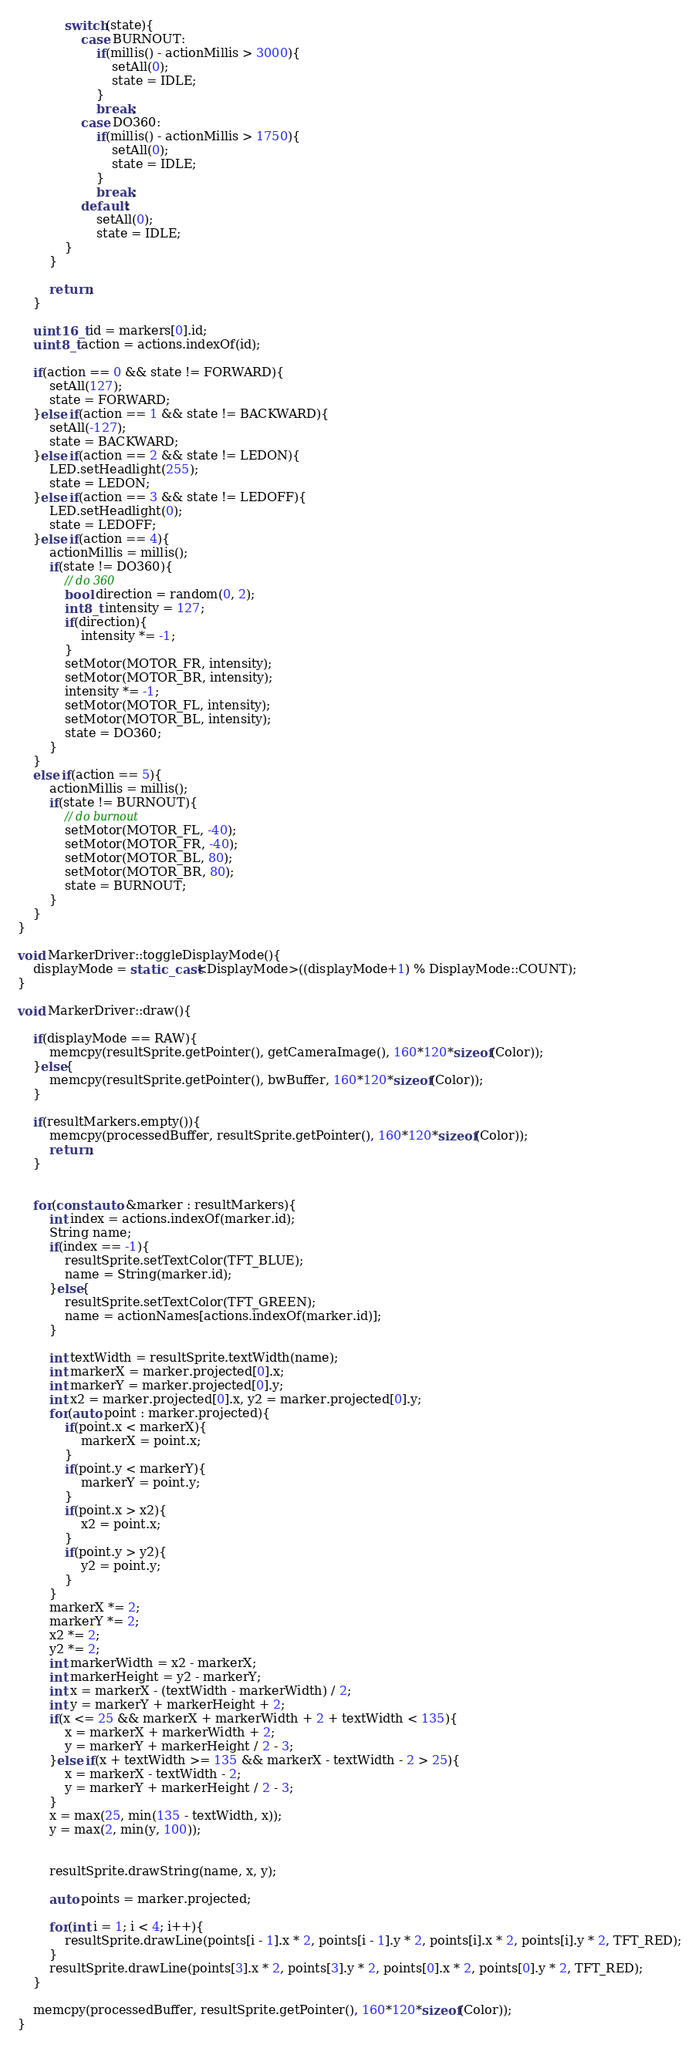Convert code to text. <code><loc_0><loc_0><loc_500><loc_500><_C++_>			switch(state){
				case BURNOUT:
					if(millis() - actionMillis > 3000){
						setAll(0);
						state = IDLE;
					}
					break;
				case DO360:
					if(millis() - actionMillis > 1750){
						setAll(0);
						state = IDLE;
					}
					break;
				default:
					setAll(0);
					state = IDLE;
			}
		}

		return;
	}

	uint16_t id = markers[0].id;
	uint8_t action = actions.indexOf(id);

	if(action == 0 && state != FORWARD){
		setAll(127);
		state = FORWARD;
	}else if(action == 1 && state != BACKWARD){
		setAll(-127);
		state = BACKWARD;
	}else if(action == 2 && state != LEDON){
		LED.setHeadlight(255);
		state = LEDON;
	}else if(action == 3 && state != LEDOFF){
		LED.setHeadlight(0);
		state = LEDOFF;
	}else if(action == 4){
		actionMillis = millis();
		if(state != DO360){
			// do 360
			bool direction = random(0, 2);
			int8_t intensity = 127;
			if(direction){
				intensity *= -1;
			}
			setMotor(MOTOR_FR, intensity);
			setMotor(MOTOR_BR, intensity);
			intensity *= -1;
			setMotor(MOTOR_FL, intensity);
			setMotor(MOTOR_BL, intensity);
			state = DO360;
		}
	}
	else if(action == 5){
		actionMillis = millis();
		if(state != BURNOUT){
			// do burnout
			setMotor(MOTOR_FL, -40);
			setMotor(MOTOR_FR, -40);
			setMotor(MOTOR_BL, 80);
			setMotor(MOTOR_BR, 80);
			state = BURNOUT;
		}
	}
}

void MarkerDriver::toggleDisplayMode(){
	displayMode = static_cast<DisplayMode>((displayMode+1) % DisplayMode::COUNT);
}

void MarkerDriver::draw(){

	if(displayMode == RAW){
		memcpy(resultSprite.getPointer(), getCameraImage(), 160*120*sizeof(Color));
	}else{
		memcpy(resultSprite.getPointer(), bwBuffer, 160*120*sizeof(Color));
	}

	if(resultMarkers.empty()){
		memcpy(processedBuffer, resultSprite.getPointer(), 160*120*sizeof(Color));
		return;
	}


	for(const auto &marker : resultMarkers){
		int index = actions.indexOf(marker.id);
		String name;
		if(index == -1){
			resultSprite.setTextColor(TFT_BLUE);
			name = String(marker.id);
		}else{
			resultSprite.setTextColor(TFT_GREEN);
			name = actionNames[actions.indexOf(marker.id)];
		}

		int textWidth = resultSprite.textWidth(name);
		int markerX = marker.projected[0].x;
		int markerY = marker.projected[0].y;
		int x2 = marker.projected[0].x, y2 = marker.projected[0].y;
		for(auto point : marker.projected){
			if(point.x < markerX){
				markerX = point.x;
			}
			if(point.y < markerY){
				markerY = point.y;
			}
			if(point.x > x2){
				x2 = point.x;
			}
			if(point.y > y2){
				y2 = point.y;
			}
		}
		markerX *= 2;
		markerY *= 2;
		x2 *= 2;
		y2 *= 2;
		int markerWidth = x2 - markerX;
		int markerHeight = y2 - markerY;
		int x = markerX - (textWidth - markerWidth) / 2;
		int y = markerY + markerHeight + 2;
		if(x <= 25 && markerX + markerWidth + 2 + textWidth < 135){
			x = markerX + markerWidth + 2;
			y = markerY + markerHeight / 2 - 3;
		}else if(x + textWidth >= 135 && markerX - textWidth - 2 > 25){
			x = markerX - textWidth - 2;
			y = markerY + markerHeight / 2 - 3;
		}
		x = max(25, min(135 - textWidth, x));
		y = max(2, min(y, 100));


		resultSprite.drawString(name, x, y);

		auto points = marker.projected;

		for(int i = 1; i < 4; i++){
			resultSprite.drawLine(points[i - 1].x * 2, points[i - 1].y * 2, points[i].x * 2, points[i].y * 2, TFT_RED);
		}
		resultSprite.drawLine(points[3].x * 2, points[3].y * 2, points[0].x * 2, points[0].y * 2, TFT_RED);
	}

	memcpy(processedBuffer, resultSprite.getPointer(), 160*120*sizeof(Color));
}
</code> 